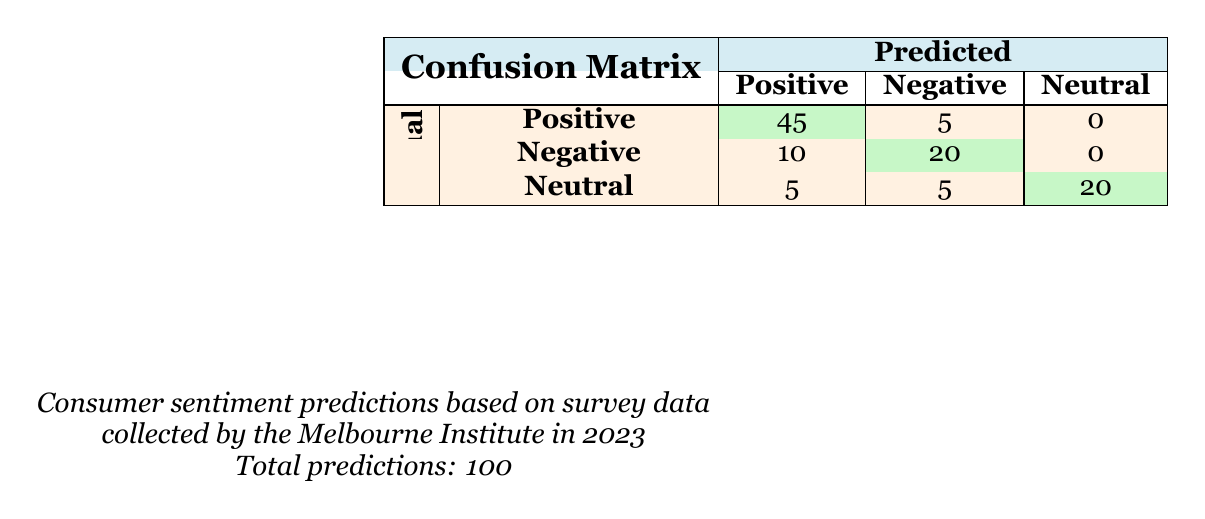What is the total number of actual positive outcomes? The actual outcomes for Positive is stated in the table as 50.
Answer: 50 How many predictions were made for Negative outcomes? To find the total predictions for Negative outcomes, we need to sum the predictions for Negative when actual is Positive, Negative, and Neutral: 5 (from Positive) + 20 (from Negative) + 5 (from Neutral) = 30.
Answer: 30 What is the count of actual Neutral predictions that were correctly predicted? The table indicates that 20 Neutral outcomes were predicted as Neutral, aligning with the actual classifications.
Answer: 20 Did the model predict more Positive outcomes than Negative outcomes? The predicted counts for Positive outcomes are 45 (for actual Positive) + 10 (for actual Negative) + 5 (for actual Neutral) = 60. The predicted counts for Negative outcomes are 5 (for actual Positive) + 20 (for actual Negative) + 5 (for actual Neutral) = 30. Since 60 is greater than 30, the answer is yes.
Answer: Yes What is the difference between the actual Positive outcomes and the correctly predicted Positive outcomes? The actual Positive outcomes are 50, while the number of correctly predicted Positive outcomes is 45. Therefore, the difference is 50 - 45 = 5.
Answer: 5 How many predictions for Neutral were misclassified as Positive? The table shows that 5 outcomes classified as Positive were actually Neutral.
Answer: 5 What percentage of actual Negative outcomes were correctly predicted? The actual Negative outcomes count is 30, and the correct predictions for Negative are 20. The percentage is (20/30) * 100 = 66.67%.
Answer: 66.67% If we consider all predictions, what percentage were correctly classified as Neutral? The total predictions made are 100, and the correct predictions for Neutral are 20. Therefore, the percentage is (20/100) * 100 = 20%.
Answer: 20% How many instances were there where actual Positive was predicted as Neutral? The table indicates that 0 instances of actual Positive were predicted as Neutral.
Answer: 0 